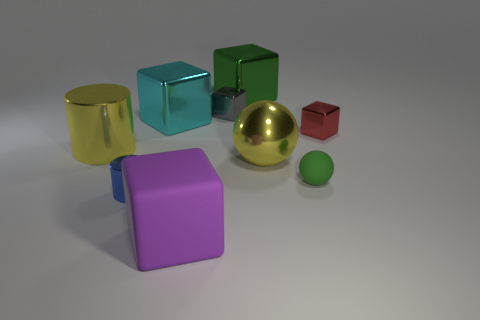How many objects are small metal objects in front of the matte sphere or tiny blue balls? In front of the matte sphere, there appears to be one small red cube, and I don’t see any tiny blue balls present in the image. Therefore, there are no small metal objects or tiny blue balls according to the description provided. 